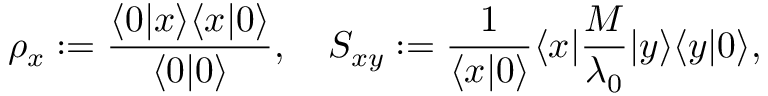<formula> <loc_0><loc_0><loc_500><loc_500>\rho _ { x } \colon = \frac { \langle 0 | x \rangle \langle x | 0 \rangle } { \langle 0 | 0 \rangle } , \quad S _ { x y } \colon = \frac { 1 } { \langle x | 0 \rangle } \langle x | \frac { M } { \lambda _ { 0 } } | y \rangle \langle y | 0 \rangle ,</formula> 